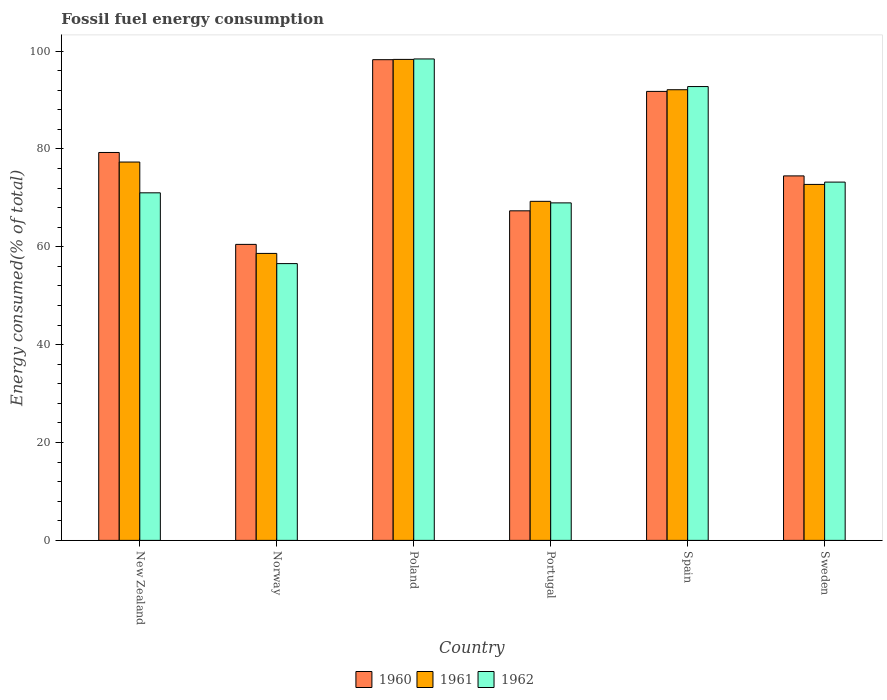How many bars are there on the 2nd tick from the left?
Keep it short and to the point. 3. How many bars are there on the 2nd tick from the right?
Offer a terse response. 3. What is the label of the 6th group of bars from the left?
Provide a succinct answer. Sweden. What is the percentage of energy consumed in 1961 in Poland?
Offer a terse response. 98.3. Across all countries, what is the maximum percentage of energy consumed in 1960?
Provide a succinct answer. 98.25. Across all countries, what is the minimum percentage of energy consumed in 1960?
Your response must be concise. 60.5. In which country was the percentage of energy consumed in 1962 maximum?
Ensure brevity in your answer.  Poland. What is the total percentage of energy consumed in 1961 in the graph?
Your answer should be very brief. 468.44. What is the difference between the percentage of energy consumed in 1962 in Spain and that in Sweden?
Your answer should be compact. 19.53. What is the difference between the percentage of energy consumed in 1960 in Portugal and the percentage of energy consumed in 1962 in Spain?
Make the answer very short. -25.4. What is the average percentage of energy consumed in 1961 per country?
Your response must be concise. 78.07. What is the difference between the percentage of energy consumed of/in 1960 and percentage of energy consumed of/in 1962 in Portugal?
Keep it short and to the point. -1.62. What is the ratio of the percentage of energy consumed in 1961 in New Zealand to that in Portugal?
Ensure brevity in your answer.  1.12. What is the difference between the highest and the second highest percentage of energy consumed in 1961?
Offer a terse response. 6.2. What is the difference between the highest and the lowest percentage of energy consumed in 1961?
Give a very brief answer. 39.65. Is the sum of the percentage of energy consumed in 1960 in Spain and Sweden greater than the maximum percentage of energy consumed in 1962 across all countries?
Your answer should be very brief. Yes. What does the 3rd bar from the left in New Zealand represents?
Provide a succinct answer. 1962. What does the 2nd bar from the right in Spain represents?
Offer a very short reply. 1961. Are all the bars in the graph horizontal?
Your answer should be very brief. No. How many countries are there in the graph?
Give a very brief answer. 6. What is the difference between two consecutive major ticks on the Y-axis?
Provide a short and direct response. 20. Does the graph contain grids?
Provide a short and direct response. No. How are the legend labels stacked?
Your answer should be compact. Horizontal. What is the title of the graph?
Offer a very short reply. Fossil fuel energy consumption. What is the label or title of the X-axis?
Ensure brevity in your answer.  Country. What is the label or title of the Y-axis?
Your response must be concise. Energy consumed(% of total). What is the Energy consumed(% of total) of 1960 in New Zealand?
Make the answer very short. 79.28. What is the Energy consumed(% of total) of 1961 in New Zealand?
Keep it short and to the point. 77.33. What is the Energy consumed(% of total) in 1962 in New Zealand?
Your answer should be compact. 71.04. What is the Energy consumed(% of total) in 1960 in Norway?
Offer a terse response. 60.5. What is the Energy consumed(% of total) of 1961 in Norway?
Your response must be concise. 58.65. What is the Energy consumed(% of total) in 1962 in Norway?
Make the answer very short. 56.57. What is the Energy consumed(% of total) in 1960 in Poland?
Provide a succinct answer. 98.25. What is the Energy consumed(% of total) in 1961 in Poland?
Offer a terse response. 98.3. What is the Energy consumed(% of total) in 1962 in Poland?
Make the answer very short. 98.4. What is the Energy consumed(% of total) of 1960 in Portugal?
Provide a short and direct response. 67.36. What is the Energy consumed(% of total) of 1961 in Portugal?
Provide a short and direct response. 69.3. What is the Energy consumed(% of total) in 1962 in Portugal?
Keep it short and to the point. 68.98. What is the Energy consumed(% of total) of 1960 in Spain?
Provide a short and direct response. 91.77. What is the Energy consumed(% of total) of 1961 in Spain?
Your response must be concise. 92.1. What is the Energy consumed(% of total) in 1962 in Spain?
Offer a terse response. 92.75. What is the Energy consumed(% of total) of 1960 in Sweden?
Give a very brief answer. 74.49. What is the Energy consumed(% of total) in 1961 in Sweden?
Provide a short and direct response. 72.75. What is the Energy consumed(% of total) in 1962 in Sweden?
Make the answer very short. 73.23. Across all countries, what is the maximum Energy consumed(% of total) in 1960?
Offer a very short reply. 98.25. Across all countries, what is the maximum Energy consumed(% of total) of 1961?
Keep it short and to the point. 98.3. Across all countries, what is the maximum Energy consumed(% of total) of 1962?
Give a very brief answer. 98.4. Across all countries, what is the minimum Energy consumed(% of total) of 1960?
Provide a succinct answer. 60.5. Across all countries, what is the minimum Energy consumed(% of total) in 1961?
Provide a succinct answer. 58.65. Across all countries, what is the minimum Energy consumed(% of total) in 1962?
Your response must be concise. 56.57. What is the total Energy consumed(% of total) in 1960 in the graph?
Your answer should be compact. 471.64. What is the total Energy consumed(% of total) in 1961 in the graph?
Your answer should be compact. 468.44. What is the total Energy consumed(% of total) of 1962 in the graph?
Give a very brief answer. 460.96. What is the difference between the Energy consumed(% of total) in 1960 in New Zealand and that in Norway?
Offer a very short reply. 18.78. What is the difference between the Energy consumed(% of total) in 1961 in New Zealand and that in Norway?
Ensure brevity in your answer.  18.68. What is the difference between the Energy consumed(% of total) in 1962 in New Zealand and that in Norway?
Offer a terse response. 14.47. What is the difference between the Energy consumed(% of total) in 1960 in New Zealand and that in Poland?
Your answer should be very brief. -18.97. What is the difference between the Energy consumed(% of total) of 1961 in New Zealand and that in Poland?
Your answer should be very brief. -20.98. What is the difference between the Energy consumed(% of total) of 1962 in New Zealand and that in Poland?
Make the answer very short. -27.36. What is the difference between the Energy consumed(% of total) of 1960 in New Zealand and that in Portugal?
Your answer should be compact. 11.92. What is the difference between the Energy consumed(% of total) in 1961 in New Zealand and that in Portugal?
Provide a succinct answer. 8.03. What is the difference between the Energy consumed(% of total) in 1962 in New Zealand and that in Portugal?
Provide a succinct answer. 2.06. What is the difference between the Energy consumed(% of total) of 1960 in New Zealand and that in Spain?
Make the answer very short. -12.49. What is the difference between the Energy consumed(% of total) of 1961 in New Zealand and that in Spain?
Provide a short and direct response. -14.78. What is the difference between the Energy consumed(% of total) in 1962 in New Zealand and that in Spain?
Provide a short and direct response. -21.72. What is the difference between the Energy consumed(% of total) in 1960 in New Zealand and that in Sweden?
Make the answer very short. 4.79. What is the difference between the Energy consumed(% of total) in 1961 in New Zealand and that in Sweden?
Offer a very short reply. 4.57. What is the difference between the Energy consumed(% of total) of 1962 in New Zealand and that in Sweden?
Provide a succinct answer. -2.19. What is the difference between the Energy consumed(% of total) of 1960 in Norway and that in Poland?
Provide a succinct answer. -37.75. What is the difference between the Energy consumed(% of total) in 1961 in Norway and that in Poland?
Provide a succinct answer. -39.65. What is the difference between the Energy consumed(% of total) of 1962 in Norway and that in Poland?
Make the answer very short. -41.83. What is the difference between the Energy consumed(% of total) in 1960 in Norway and that in Portugal?
Keep it short and to the point. -6.86. What is the difference between the Energy consumed(% of total) in 1961 in Norway and that in Portugal?
Make the answer very short. -10.64. What is the difference between the Energy consumed(% of total) of 1962 in Norway and that in Portugal?
Provide a succinct answer. -12.41. What is the difference between the Energy consumed(% of total) in 1960 in Norway and that in Spain?
Your answer should be compact. -31.27. What is the difference between the Energy consumed(% of total) in 1961 in Norway and that in Spain?
Keep it short and to the point. -33.45. What is the difference between the Energy consumed(% of total) of 1962 in Norway and that in Spain?
Provide a short and direct response. -36.18. What is the difference between the Energy consumed(% of total) of 1960 in Norway and that in Sweden?
Your answer should be compact. -14. What is the difference between the Energy consumed(% of total) of 1961 in Norway and that in Sweden?
Offer a very short reply. -14.1. What is the difference between the Energy consumed(% of total) in 1962 in Norway and that in Sweden?
Offer a terse response. -16.66. What is the difference between the Energy consumed(% of total) of 1960 in Poland and that in Portugal?
Ensure brevity in your answer.  30.89. What is the difference between the Energy consumed(% of total) of 1961 in Poland and that in Portugal?
Keep it short and to the point. 29.01. What is the difference between the Energy consumed(% of total) in 1962 in Poland and that in Portugal?
Make the answer very short. 29.42. What is the difference between the Energy consumed(% of total) in 1960 in Poland and that in Spain?
Offer a terse response. 6.48. What is the difference between the Energy consumed(% of total) in 1961 in Poland and that in Spain?
Make the answer very short. 6.2. What is the difference between the Energy consumed(% of total) in 1962 in Poland and that in Spain?
Provide a succinct answer. 5.64. What is the difference between the Energy consumed(% of total) in 1960 in Poland and that in Sweden?
Provide a succinct answer. 23.75. What is the difference between the Energy consumed(% of total) in 1961 in Poland and that in Sweden?
Ensure brevity in your answer.  25.55. What is the difference between the Energy consumed(% of total) in 1962 in Poland and that in Sweden?
Give a very brief answer. 25.17. What is the difference between the Energy consumed(% of total) of 1960 in Portugal and that in Spain?
Provide a succinct answer. -24.41. What is the difference between the Energy consumed(% of total) of 1961 in Portugal and that in Spain?
Provide a short and direct response. -22.81. What is the difference between the Energy consumed(% of total) in 1962 in Portugal and that in Spain?
Provide a succinct answer. -23.77. What is the difference between the Energy consumed(% of total) in 1960 in Portugal and that in Sweden?
Give a very brief answer. -7.14. What is the difference between the Energy consumed(% of total) of 1961 in Portugal and that in Sweden?
Your answer should be very brief. -3.46. What is the difference between the Energy consumed(% of total) of 1962 in Portugal and that in Sweden?
Offer a terse response. -4.25. What is the difference between the Energy consumed(% of total) of 1960 in Spain and that in Sweden?
Your answer should be very brief. 17.27. What is the difference between the Energy consumed(% of total) of 1961 in Spain and that in Sweden?
Your answer should be very brief. 19.35. What is the difference between the Energy consumed(% of total) of 1962 in Spain and that in Sweden?
Give a very brief answer. 19.53. What is the difference between the Energy consumed(% of total) in 1960 in New Zealand and the Energy consumed(% of total) in 1961 in Norway?
Your answer should be compact. 20.63. What is the difference between the Energy consumed(% of total) in 1960 in New Zealand and the Energy consumed(% of total) in 1962 in Norway?
Offer a very short reply. 22.71. What is the difference between the Energy consumed(% of total) of 1961 in New Zealand and the Energy consumed(% of total) of 1962 in Norway?
Offer a terse response. 20.76. What is the difference between the Energy consumed(% of total) in 1960 in New Zealand and the Energy consumed(% of total) in 1961 in Poland?
Keep it short and to the point. -19.02. What is the difference between the Energy consumed(% of total) in 1960 in New Zealand and the Energy consumed(% of total) in 1962 in Poland?
Provide a short and direct response. -19.12. What is the difference between the Energy consumed(% of total) of 1961 in New Zealand and the Energy consumed(% of total) of 1962 in Poland?
Your answer should be very brief. -21.07. What is the difference between the Energy consumed(% of total) in 1960 in New Zealand and the Energy consumed(% of total) in 1961 in Portugal?
Your response must be concise. 9.98. What is the difference between the Energy consumed(% of total) in 1960 in New Zealand and the Energy consumed(% of total) in 1962 in Portugal?
Your response must be concise. 10.3. What is the difference between the Energy consumed(% of total) of 1961 in New Zealand and the Energy consumed(% of total) of 1962 in Portugal?
Provide a succinct answer. 8.35. What is the difference between the Energy consumed(% of total) in 1960 in New Zealand and the Energy consumed(% of total) in 1961 in Spain?
Your response must be concise. -12.83. What is the difference between the Energy consumed(% of total) in 1960 in New Zealand and the Energy consumed(% of total) in 1962 in Spain?
Your response must be concise. -13.47. What is the difference between the Energy consumed(% of total) in 1961 in New Zealand and the Energy consumed(% of total) in 1962 in Spain?
Your answer should be compact. -15.43. What is the difference between the Energy consumed(% of total) in 1960 in New Zealand and the Energy consumed(% of total) in 1961 in Sweden?
Keep it short and to the point. 6.53. What is the difference between the Energy consumed(% of total) in 1960 in New Zealand and the Energy consumed(% of total) in 1962 in Sweden?
Your response must be concise. 6.05. What is the difference between the Energy consumed(% of total) of 1961 in New Zealand and the Energy consumed(% of total) of 1962 in Sweden?
Ensure brevity in your answer.  4.1. What is the difference between the Energy consumed(% of total) of 1960 in Norway and the Energy consumed(% of total) of 1961 in Poland?
Provide a short and direct response. -37.81. What is the difference between the Energy consumed(% of total) in 1960 in Norway and the Energy consumed(% of total) in 1962 in Poland?
Your answer should be compact. -37.9. What is the difference between the Energy consumed(% of total) in 1961 in Norway and the Energy consumed(% of total) in 1962 in Poland?
Your response must be concise. -39.74. What is the difference between the Energy consumed(% of total) of 1960 in Norway and the Energy consumed(% of total) of 1961 in Portugal?
Your response must be concise. -8.8. What is the difference between the Energy consumed(% of total) in 1960 in Norway and the Energy consumed(% of total) in 1962 in Portugal?
Offer a very short reply. -8.48. What is the difference between the Energy consumed(% of total) of 1961 in Norway and the Energy consumed(% of total) of 1962 in Portugal?
Provide a short and direct response. -10.33. What is the difference between the Energy consumed(% of total) in 1960 in Norway and the Energy consumed(% of total) in 1961 in Spain?
Provide a succinct answer. -31.61. What is the difference between the Energy consumed(% of total) in 1960 in Norway and the Energy consumed(% of total) in 1962 in Spain?
Your answer should be compact. -32.26. What is the difference between the Energy consumed(% of total) of 1961 in Norway and the Energy consumed(% of total) of 1962 in Spain?
Your answer should be compact. -34.1. What is the difference between the Energy consumed(% of total) of 1960 in Norway and the Energy consumed(% of total) of 1961 in Sweden?
Your answer should be compact. -12.26. What is the difference between the Energy consumed(% of total) in 1960 in Norway and the Energy consumed(% of total) in 1962 in Sweden?
Ensure brevity in your answer.  -12.73. What is the difference between the Energy consumed(% of total) in 1961 in Norway and the Energy consumed(% of total) in 1962 in Sweden?
Keep it short and to the point. -14.57. What is the difference between the Energy consumed(% of total) in 1960 in Poland and the Energy consumed(% of total) in 1961 in Portugal?
Ensure brevity in your answer.  28.95. What is the difference between the Energy consumed(% of total) in 1960 in Poland and the Energy consumed(% of total) in 1962 in Portugal?
Your answer should be compact. 29.27. What is the difference between the Energy consumed(% of total) of 1961 in Poland and the Energy consumed(% of total) of 1962 in Portugal?
Offer a very short reply. 29.32. What is the difference between the Energy consumed(% of total) in 1960 in Poland and the Energy consumed(% of total) in 1961 in Spain?
Provide a short and direct response. 6.14. What is the difference between the Energy consumed(% of total) in 1960 in Poland and the Energy consumed(% of total) in 1962 in Spain?
Offer a very short reply. 5.49. What is the difference between the Energy consumed(% of total) of 1961 in Poland and the Energy consumed(% of total) of 1962 in Spain?
Ensure brevity in your answer.  5.55. What is the difference between the Energy consumed(% of total) of 1960 in Poland and the Energy consumed(% of total) of 1961 in Sweden?
Ensure brevity in your answer.  25.49. What is the difference between the Energy consumed(% of total) in 1960 in Poland and the Energy consumed(% of total) in 1962 in Sweden?
Keep it short and to the point. 25.02. What is the difference between the Energy consumed(% of total) of 1961 in Poland and the Energy consumed(% of total) of 1962 in Sweden?
Offer a terse response. 25.08. What is the difference between the Energy consumed(% of total) of 1960 in Portugal and the Energy consumed(% of total) of 1961 in Spain?
Your response must be concise. -24.75. What is the difference between the Energy consumed(% of total) of 1960 in Portugal and the Energy consumed(% of total) of 1962 in Spain?
Your answer should be very brief. -25.4. What is the difference between the Energy consumed(% of total) in 1961 in Portugal and the Energy consumed(% of total) in 1962 in Spain?
Your response must be concise. -23.46. What is the difference between the Energy consumed(% of total) in 1960 in Portugal and the Energy consumed(% of total) in 1961 in Sweden?
Ensure brevity in your answer.  -5.4. What is the difference between the Energy consumed(% of total) of 1960 in Portugal and the Energy consumed(% of total) of 1962 in Sweden?
Keep it short and to the point. -5.87. What is the difference between the Energy consumed(% of total) of 1961 in Portugal and the Energy consumed(% of total) of 1962 in Sweden?
Your answer should be very brief. -3.93. What is the difference between the Energy consumed(% of total) of 1960 in Spain and the Energy consumed(% of total) of 1961 in Sweden?
Provide a short and direct response. 19.01. What is the difference between the Energy consumed(% of total) in 1960 in Spain and the Energy consumed(% of total) in 1962 in Sweden?
Keep it short and to the point. 18.54. What is the difference between the Energy consumed(% of total) in 1961 in Spain and the Energy consumed(% of total) in 1962 in Sweden?
Offer a terse response. 18.88. What is the average Energy consumed(% of total) of 1960 per country?
Keep it short and to the point. 78.61. What is the average Energy consumed(% of total) in 1961 per country?
Give a very brief answer. 78.07. What is the average Energy consumed(% of total) in 1962 per country?
Keep it short and to the point. 76.83. What is the difference between the Energy consumed(% of total) of 1960 and Energy consumed(% of total) of 1961 in New Zealand?
Offer a terse response. 1.95. What is the difference between the Energy consumed(% of total) of 1960 and Energy consumed(% of total) of 1962 in New Zealand?
Your answer should be very brief. 8.24. What is the difference between the Energy consumed(% of total) in 1961 and Energy consumed(% of total) in 1962 in New Zealand?
Keep it short and to the point. 6.29. What is the difference between the Energy consumed(% of total) of 1960 and Energy consumed(% of total) of 1961 in Norway?
Make the answer very short. 1.85. What is the difference between the Energy consumed(% of total) in 1960 and Energy consumed(% of total) in 1962 in Norway?
Offer a very short reply. 3.93. What is the difference between the Energy consumed(% of total) in 1961 and Energy consumed(% of total) in 1962 in Norway?
Provide a succinct answer. 2.08. What is the difference between the Energy consumed(% of total) of 1960 and Energy consumed(% of total) of 1961 in Poland?
Your answer should be compact. -0.06. What is the difference between the Energy consumed(% of total) of 1960 and Energy consumed(% of total) of 1962 in Poland?
Offer a terse response. -0.15. What is the difference between the Energy consumed(% of total) in 1961 and Energy consumed(% of total) in 1962 in Poland?
Provide a succinct answer. -0.09. What is the difference between the Energy consumed(% of total) in 1960 and Energy consumed(% of total) in 1961 in Portugal?
Your answer should be compact. -1.94. What is the difference between the Energy consumed(% of total) of 1960 and Energy consumed(% of total) of 1962 in Portugal?
Make the answer very short. -1.62. What is the difference between the Energy consumed(% of total) in 1961 and Energy consumed(% of total) in 1962 in Portugal?
Give a very brief answer. 0.32. What is the difference between the Energy consumed(% of total) of 1960 and Energy consumed(% of total) of 1961 in Spain?
Your response must be concise. -0.34. What is the difference between the Energy consumed(% of total) in 1960 and Energy consumed(% of total) in 1962 in Spain?
Make the answer very short. -0.99. What is the difference between the Energy consumed(% of total) in 1961 and Energy consumed(% of total) in 1962 in Spain?
Your answer should be compact. -0.65. What is the difference between the Energy consumed(% of total) in 1960 and Energy consumed(% of total) in 1961 in Sweden?
Keep it short and to the point. 1.74. What is the difference between the Energy consumed(% of total) of 1960 and Energy consumed(% of total) of 1962 in Sweden?
Make the answer very short. 1.27. What is the difference between the Energy consumed(% of total) in 1961 and Energy consumed(% of total) in 1962 in Sweden?
Offer a terse response. -0.47. What is the ratio of the Energy consumed(% of total) of 1960 in New Zealand to that in Norway?
Your response must be concise. 1.31. What is the ratio of the Energy consumed(% of total) in 1961 in New Zealand to that in Norway?
Your answer should be compact. 1.32. What is the ratio of the Energy consumed(% of total) of 1962 in New Zealand to that in Norway?
Provide a short and direct response. 1.26. What is the ratio of the Energy consumed(% of total) in 1960 in New Zealand to that in Poland?
Offer a very short reply. 0.81. What is the ratio of the Energy consumed(% of total) in 1961 in New Zealand to that in Poland?
Keep it short and to the point. 0.79. What is the ratio of the Energy consumed(% of total) in 1962 in New Zealand to that in Poland?
Your answer should be very brief. 0.72. What is the ratio of the Energy consumed(% of total) of 1960 in New Zealand to that in Portugal?
Give a very brief answer. 1.18. What is the ratio of the Energy consumed(% of total) in 1961 in New Zealand to that in Portugal?
Your answer should be compact. 1.12. What is the ratio of the Energy consumed(% of total) in 1962 in New Zealand to that in Portugal?
Offer a very short reply. 1.03. What is the ratio of the Energy consumed(% of total) in 1960 in New Zealand to that in Spain?
Provide a succinct answer. 0.86. What is the ratio of the Energy consumed(% of total) in 1961 in New Zealand to that in Spain?
Ensure brevity in your answer.  0.84. What is the ratio of the Energy consumed(% of total) of 1962 in New Zealand to that in Spain?
Give a very brief answer. 0.77. What is the ratio of the Energy consumed(% of total) in 1960 in New Zealand to that in Sweden?
Provide a succinct answer. 1.06. What is the ratio of the Energy consumed(% of total) of 1961 in New Zealand to that in Sweden?
Provide a short and direct response. 1.06. What is the ratio of the Energy consumed(% of total) in 1962 in New Zealand to that in Sweden?
Keep it short and to the point. 0.97. What is the ratio of the Energy consumed(% of total) in 1960 in Norway to that in Poland?
Ensure brevity in your answer.  0.62. What is the ratio of the Energy consumed(% of total) in 1961 in Norway to that in Poland?
Ensure brevity in your answer.  0.6. What is the ratio of the Energy consumed(% of total) in 1962 in Norway to that in Poland?
Provide a succinct answer. 0.57. What is the ratio of the Energy consumed(% of total) in 1960 in Norway to that in Portugal?
Provide a succinct answer. 0.9. What is the ratio of the Energy consumed(% of total) of 1961 in Norway to that in Portugal?
Provide a succinct answer. 0.85. What is the ratio of the Energy consumed(% of total) of 1962 in Norway to that in Portugal?
Provide a succinct answer. 0.82. What is the ratio of the Energy consumed(% of total) of 1960 in Norway to that in Spain?
Ensure brevity in your answer.  0.66. What is the ratio of the Energy consumed(% of total) in 1961 in Norway to that in Spain?
Make the answer very short. 0.64. What is the ratio of the Energy consumed(% of total) of 1962 in Norway to that in Spain?
Offer a very short reply. 0.61. What is the ratio of the Energy consumed(% of total) in 1960 in Norway to that in Sweden?
Your answer should be very brief. 0.81. What is the ratio of the Energy consumed(% of total) in 1961 in Norway to that in Sweden?
Your response must be concise. 0.81. What is the ratio of the Energy consumed(% of total) in 1962 in Norway to that in Sweden?
Keep it short and to the point. 0.77. What is the ratio of the Energy consumed(% of total) of 1960 in Poland to that in Portugal?
Provide a short and direct response. 1.46. What is the ratio of the Energy consumed(% of total) of 1961 in Poland to that in Portugal?
Make the answer very short. 1.42. What is the ratio of the Energy consumed(% of total) of 1962 in Poland to that in Portugal?
Make the answer very short. 1.43. What is the ratio of the Energy consumed(% of total) of 1960 in Poland to that in Spain?
Provide a short and direct response. 1.07. What is the ratio of the Energy consumed(% of total) in 1961 in Poland to that in Spain?
Keep it short and to the point. 1.07. What is the ratio of the Energy consumed(% of total) in 1962 in Poland to that in Spain?
Your answer should be compact. 1.06. What is the ratio of the Energy consumed(% of total) in 1960 in Poland to that in Sweden?
Ensure brevity in your answer.  1.32. What is the ratio of the Energy consumed(% of total) of 1961 in Poland to that in Sweden?
Your answer should be very brief. 1.35. What is the ratio of the Energy consumed(% of total) in 1962 in Poland to that in Sweden?
Your answer should be very brief. 1.34. What is the ratio of the Energy consumed(% of total) of 1960 in Portugal to that in Spain?
Offer a very short reply. 0.73. What is the ratio of the Energy consumed(% of total) of 1961 in Portugal to that in Spain?
Make the answer very short. 0.75. What is the ratio of the Energy consumed(% of total) in 1962 in Portugal to that in Spain?
Provide a short and direct response. 0.74. What is the ratio of the Energy consumed(% of total) in 1960 in Portugal to that in Sweden?
Provide a short and direct response. 0.9. What is the ratio of the Energy consumed(% of total) of 1961 in Portugal to that in Sweden?
Ensure brevity in your answer.  0.95. What is the ratio of the Energy consumed(% of total) of 1962 in Portugal to that in Sweden?
Your answer should be compact. 0.94. What is the ratio of the Energy consumed(% of total) of 1960 in Spain to that in Sweden?
Keep it short and to the point. 1.23. What is the ratio of the Energy consumed(% of total) of 1961 in Spain to that in Sweden?
Give a very brief answer. 1.27. What is the ratio of the Energy consumed(% of total) of 1962 in Spain to that in Sweden?
Ensure brevity in your answer.  1.27. What is the difference between the highest and the second highest Energy consumed(% of total) of 1960?
Offer a very short reply. 6.48. What is the difference between the highest and the second highest Energy consumed(% of total) of 1961?
Provide a short and direct response. 6.2. What is the difference between the highest and the second highest Energy consumed(% of total) in 1962?
Provide a succinct answer. 5.64. What is the difference between the highest and the lowest Energy consumed(% of total) in 1960?
Ensure brevity in your answer.  37.75. What is the difference between the highest and the lowest Energy consumed(% of total) in 1961?
Your response must be concise. 39.65. What is the difference between the highest and the lowest Energy consumed(% of total) in 1962?
Give a very brief answer. 41.83. 